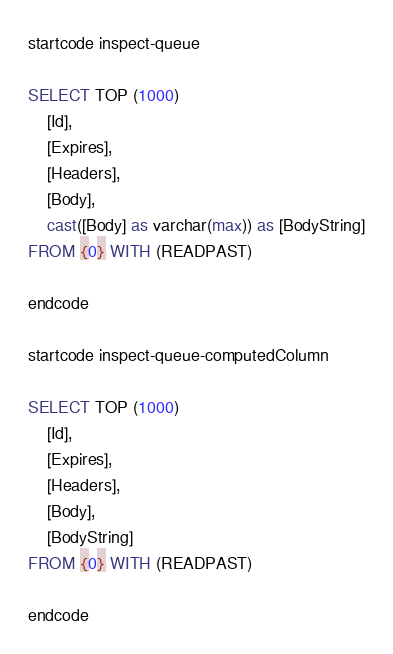<code> <loc_0><loc_0><loc_500><loc_500><_SQL_>startcode inspect-queue

SELECT TOP (1000) 
    [Id],
    [Expires],
    [Headers],
    [Body],
    cast([Body] as varchar(max)) as [BodyString]
FROM {0} WITH (READPAST)

endcode

startcode inspect-queue-computedColumn

SELECT TOP (1000) 
    [Id],
    [Expires],
    [Headers],
    [Body],
    [BodyString]
FROM {0} WITH (READPAST)

endcode

</code> 